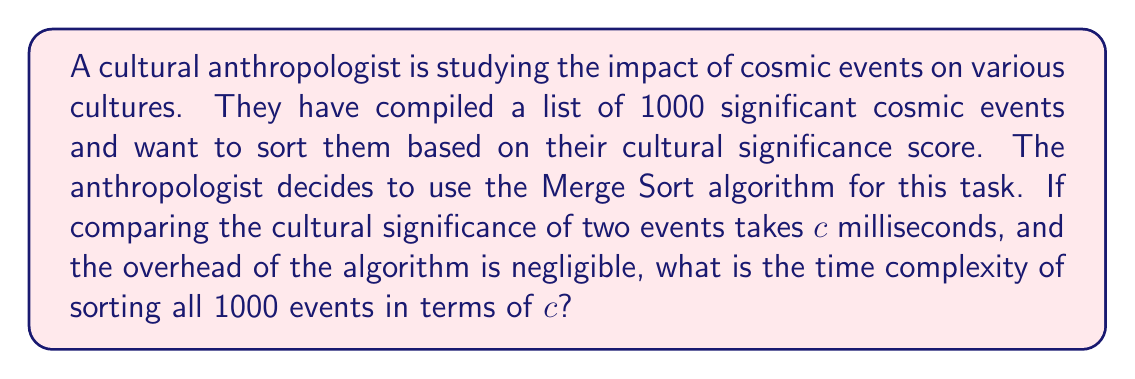Provide a solution to this math problem. To solve this problem, we need to follow these steps:

1) Recall the time complexity of Merge Sort:
   Merge Sort has a time complexity of $O(n \log n)$, where $n$ is the number of elements to be sorted.

2) In this case, $n = 1000$ (the number of cosmic events).

3) Each comparison takes $c$ milliseconds. This is our basic operation.

4) The total number of comparisons in Merge Sort is proportional to $n \log n$.

5) Therefore, the total time taken will be:
   $T(n) = c \cdot n \log n$

6) Substituting $n = 1000$:
   $T(1000) = c \cdot 1000 \log 1000$

7) $\log 1000 \approx 9.966$ (using base 2 logarithm, which is standard in computer science)

8) Therefore:
   $T(1000) \approx c \cdot 1000 \cdot 9.966 = 9966c$ milliseconds

This means the algorithm will take approximately $9966c$ milliseconds to sort all 1000 cosmic events based on their cultural significance.
Answer: The time complexity of sorting 1000 cosmic events using Merge Sort is approximately $9966c$ milliseconds, where $c$ is the time taken for a single comparison. 